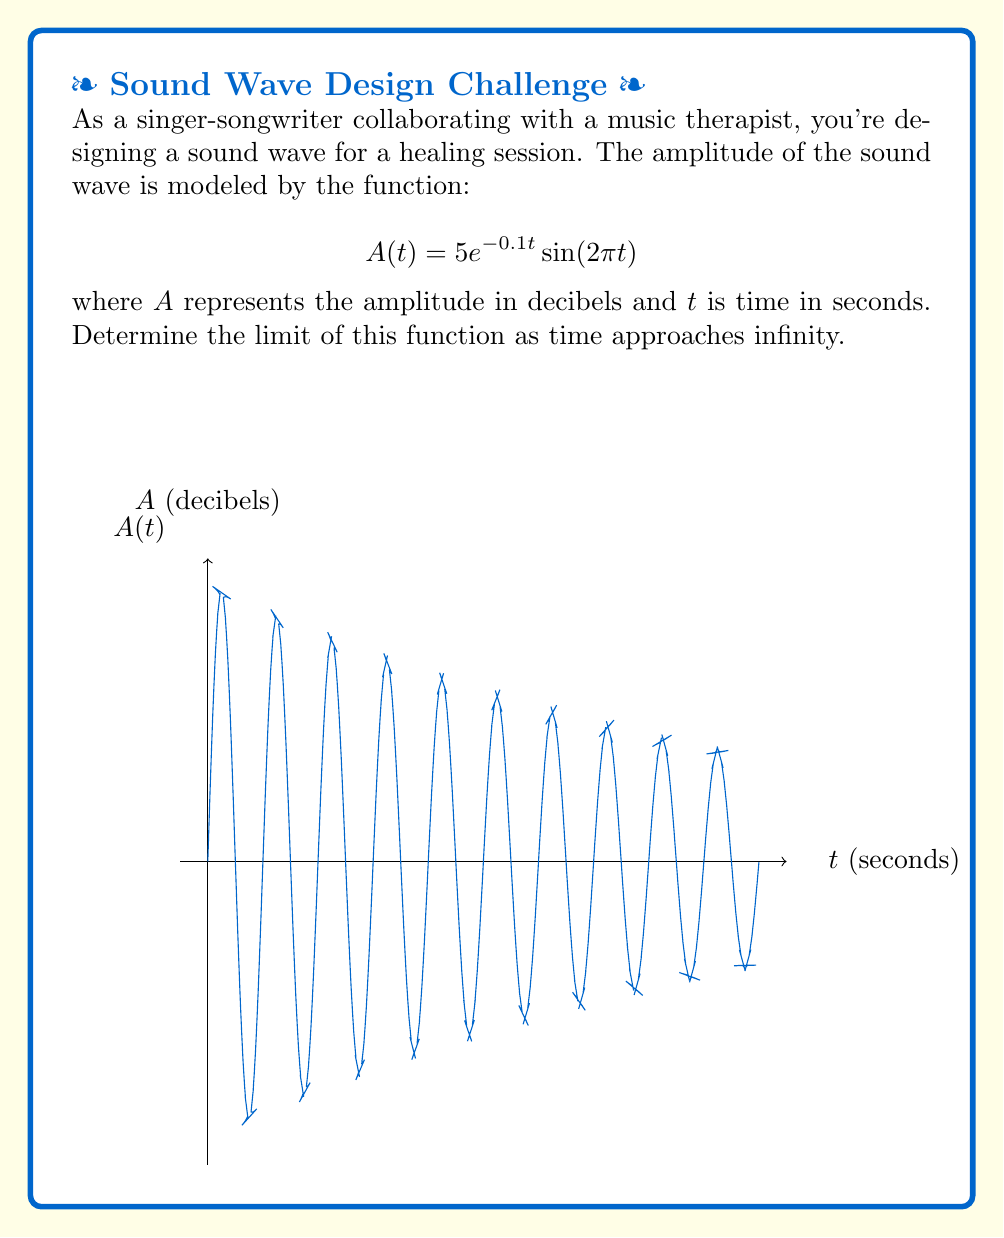Could you help me with this problem? Let's approach this step-by-step:

1) We need to evaluate $\lim_{t \to \infty} 5e^{-0.1t} \sin(2\pi t)$

2) First, let's consider the behavior of each part of the function as $t$ approaches infinity:

   a) $5$ is a constant, so it doesn't change as $t$ increases.
   
   b) $e^{-0.1t}$ approaches 0 as $t$ approaches infinity because the exponent becomes a large negative number.
   
   c) $\sin(2\pi t)$ oscillates between -1 and 1 indefinitely as $t$ increases.

3) We can use the following limit property:
   If $\lim_{t \to \infty} f(t) = 0$ and $g(t)$ is bounded, then $\lim_{t \to \infty} f(t)g(t) = 0$

4) In our case:
   - $f(t) = 5e^{-0.1t}$ (approaches 0 as $t$ approaches infinity)
   - $g(t) = \sin(2\pi t)$ (bounded between -1 and 1)

5) Therefore, as $t$ approaches infinity, the exponential decay term $5e^{-0.1t}$ will approach 0 faster than $\sin(2\pi t)$ oscillates.

6) This means that the overall amplitude of the sound wave will decrease over time, eventually becoming imperceptible.

Thus, the limit of the function as time approaches infinity is 0.
Answer: $0$ 